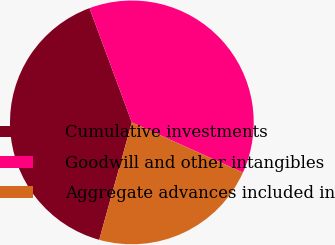Convert chart to OTSL. <chart><loc_0><loc_0><loc_500><loc_500><pie_chart><fcel>Cumulative investments<fcel>Goodwill and other intangibles<fcel>Aggregate advances included in<nl><fcel>40.04%<fcel>37.4%<fcel>22.56%<nl></chart> 